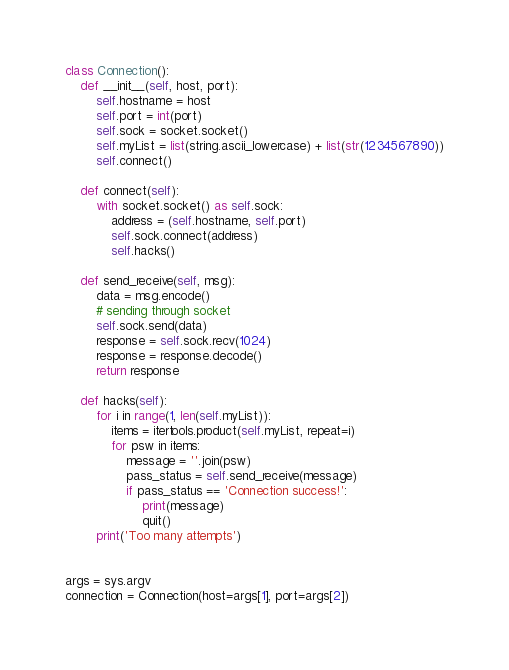<code> <loc_0><loc_0><loc_500><loc_500><_Python_>
class Connection():
    def __init__(self, host, port):
        self.hostname = host
        self.port = int(port)
        self.sock = socket.socket()
        self.myList = list(string.ascii_lowercase) + list(str(1234567890))
        self.connect()

    def connect(self):
        with socket.socket() as self.sock:
            address = (self.hostname, self.port)
            self.sock.connect(address)
            self.hacks()

    def send_receive(self, msg):
        data = msg.encode()
        # sending through socket
        self.sock.send(data)
        response = self.sock.recv(1024)
        response = response.decode()
        return response

    def hacks(self):
        for i in range(1, len(self.myList)):
            items = itertools.product(self.myList, repeat=i)
            for psw in items:
                message = ''.join(psw)
                pass_status = self.send_receive(message)
                if pass_status == 'Connection success!':
                    print(message)
                    quit()
        print('Too many attempts')


args = sys.argv
connection = Connection(host=args[1], port=args[2])
</code> 